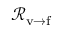Convert formula to latex. <formula><loc_0><loc_0><loc_500><loc_500>{ \mathcal { R } } _ { v \rightarrow f }</formula> 